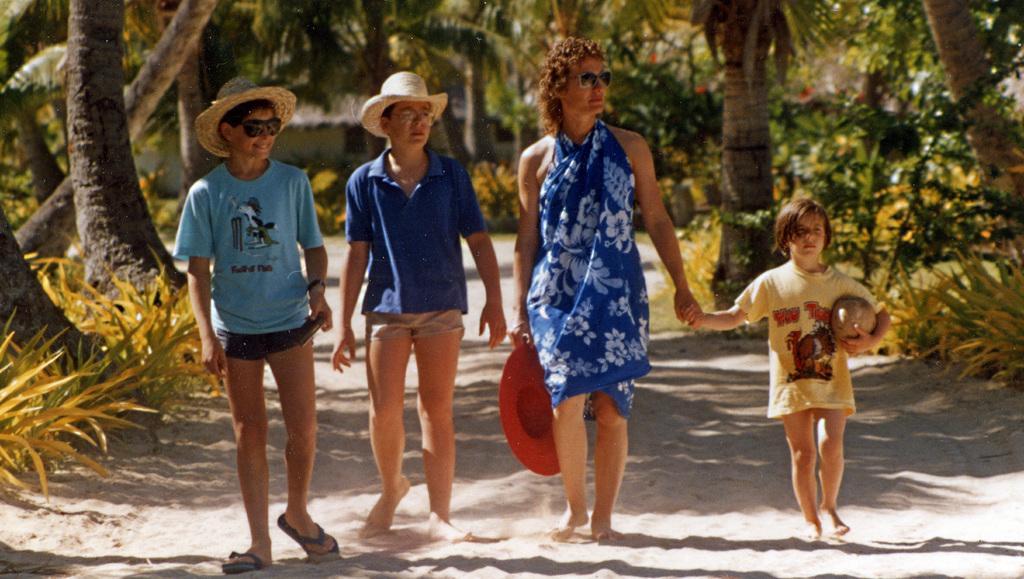Could you give a brief overview of what you see in this image? This image is taken outdoors. At the bottom of the image there is a ground with sand. In the background there are many trees and plants. In the middle of the image a kid and a woman and two boys are walking on the ground. Two boys have worn hats and a woman is holding a hat in her hand. 